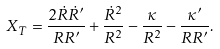Convert formula to latex. <formula><loc_0><loc_0><loc_500><loc_500>X _ { T } = \frac { 2 \dot { R } \dot { R } ^ { \prime } } { R R ^ { \prime } } + \frac { \dot { R } ^ { 2 } } { R ^ { 2 } } - \frac { \kappa } { R ^ { 2 } } - \frac { \kappa ^ { \prime } } { R R ^ { \prime } } .</formula> 